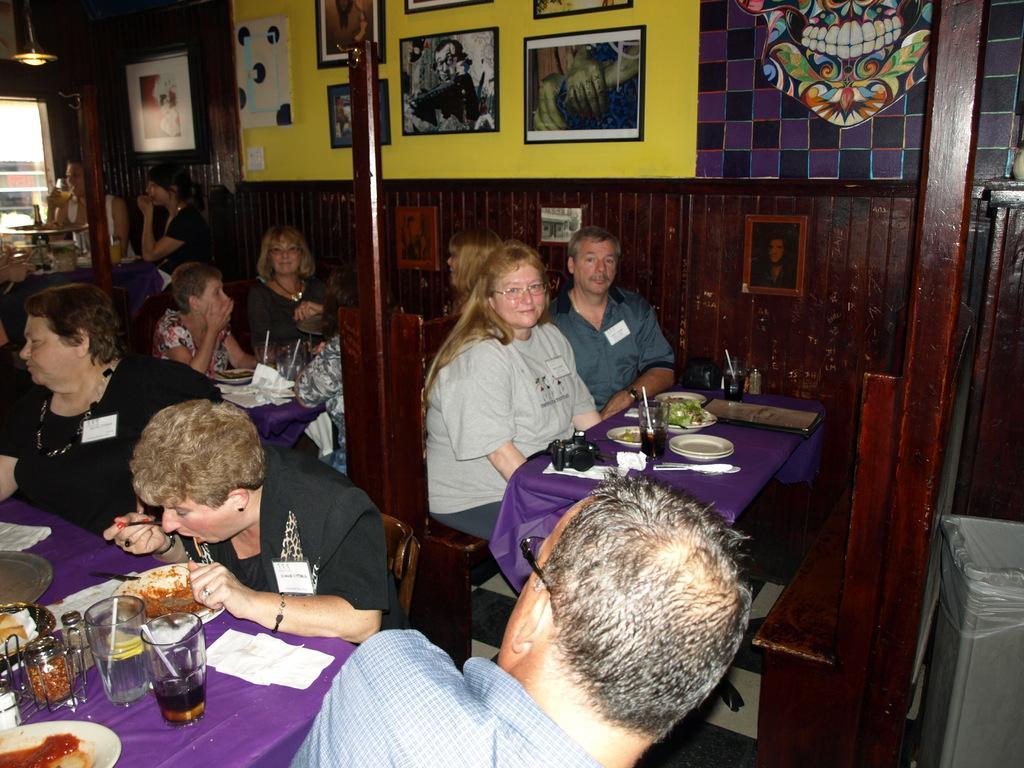In one or two sentences, can you explain what this image depicts? In this picture we can see a group of people sitting on chairs and in front of them on table we have glasses with drinks and straw in it, bottles, plate with some food item, menu card, camera, tissue paper and in the background we can see wall with frame, light, window, some person. 